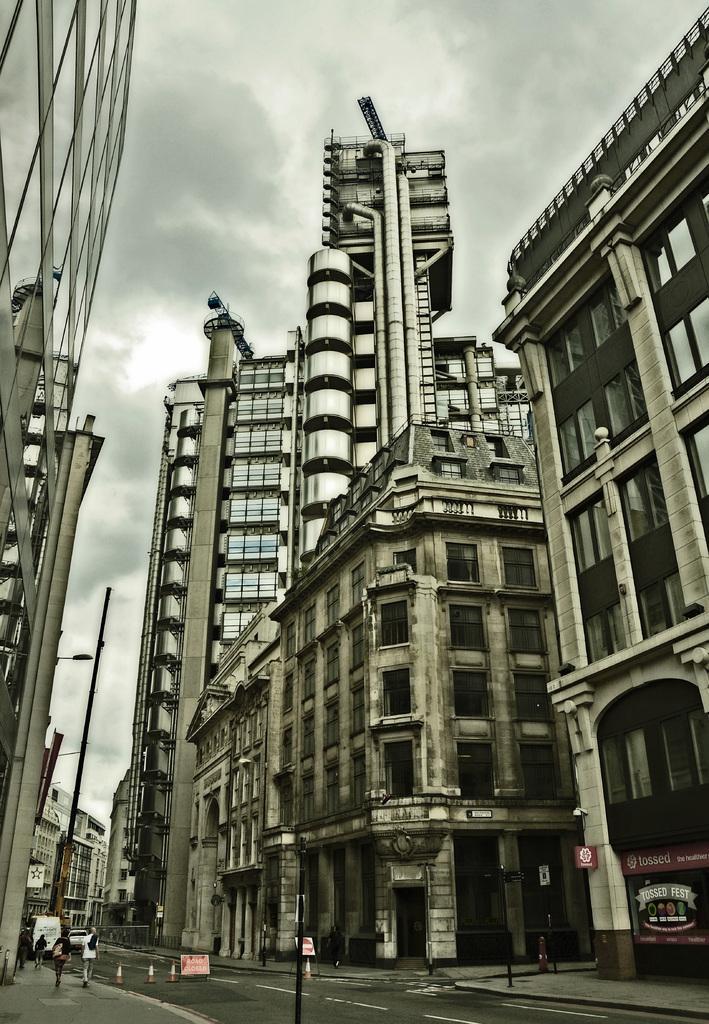How would you summarize this image in a sentence or two? In this image there is a road in the middle and there are tall buildings on either side of the road. On the road there are vehicles. On the foot path there are few people walking on it and there are street lights on the footpath. At the top there is sky. 